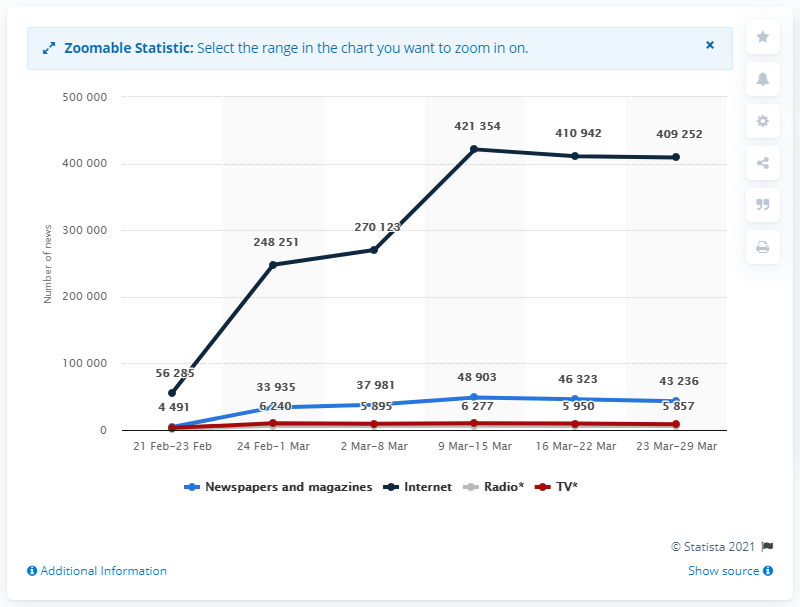What does this chart tell us about the popularity of different media outlets over time? The chart shows the number of news releases for various media outlets over time, ranging from February 21 to March 29. It indicates that Internet sources consistently have the highest number of releases and show a significant growth, whereas Newspapers and magazines, Radio, and TV have considerably less and display a relatively stable release pattern without substantial growth. 